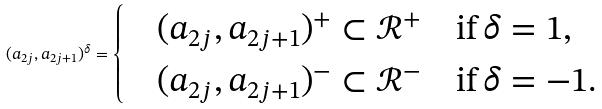Convert formula to latex. <formula><loc_0><loc_0><loc_500><loc_500>( a _ { 2 j } , a _ { 2 j + 1 } ) ^ { \delta } = \begin{cases} & ( a _ { 2 j } , a _ { 2 j + 1 } ) ^ { + } \subset \mathcal { R } ^ { + } \quad \text {if} \, \delta = 1 , \\ & ( a _ { 2 j } , a _ { 2 j + 1 } ) ^ { - } \subset \mathcal { R } ^ { - } \quad \text {if} \, \delta = - 1 . \end{cases}</formula> 